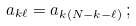Convert formula to latex. <formula><loc_0><loc_0><loc_500><loc_500>a _ { k \ell } = a _ { k ( N - k - \ell ) } \, ;</formula> 